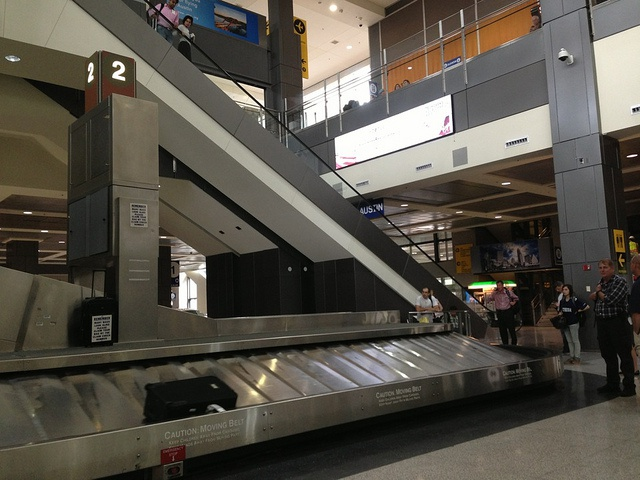Describe the objects in this image and their specific colors. I can see people in gray, black, and maroon tones, suitcase in gray, black, and darkgray tones, suitcase in gray and black tones, people in gray and black tones, and people in gray, black, brown, and maroon tones in this image. 